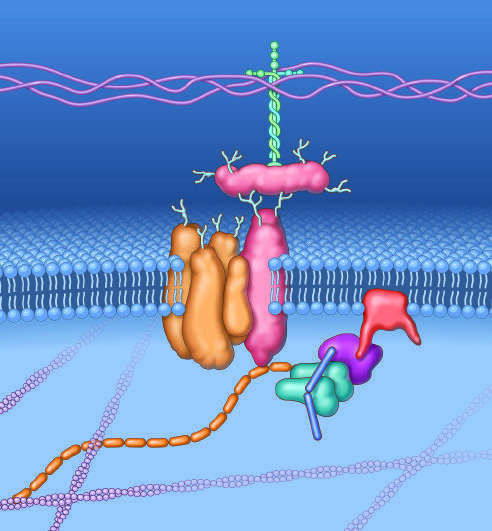what serves to couple the cell membrane to extracellular matrix proteins such as laminin-2 and the intracellular cytoskeleton?
Answer the question using a single word or phrase. The complex of glycoproteins 